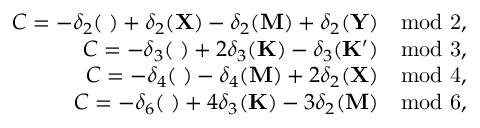Convert formula to latex. <formula><loc_0><loc_0><loc_500><loc_500>\begin{array} { r } { C = - \delta _ { 2 } ( { \Gamma } ) + \delta _ { 2 } ( { X } ) - \delta _ { 2 } ( { M } ) + \delta _ { 2 } ( { Y } ) \quad m o d 2 , } \\ { C = - \delta _ { 3 } ( { \Gamma } ) + 2 \delta _ { 3 } ( { K } ) - \delta _ { 3 } ( { K ^ { \prime } } ) \quad m o d 3 , } \\ { C = - \delta _ { 4 } ( { \Gamma } ) - \delta _ { 4 } ( { M } ) + 2 \delta _ { 2 } ( { X } ) \quad m o d 4 , } \\ { C = - \delta _ { 6 } ( { \Gamma } ) + 4 \delta _ { 3 } ( { K } ) - 3 \delta _ { 2 } ( { M } ) \quad m o d 6 , } \end{array}</formula> 